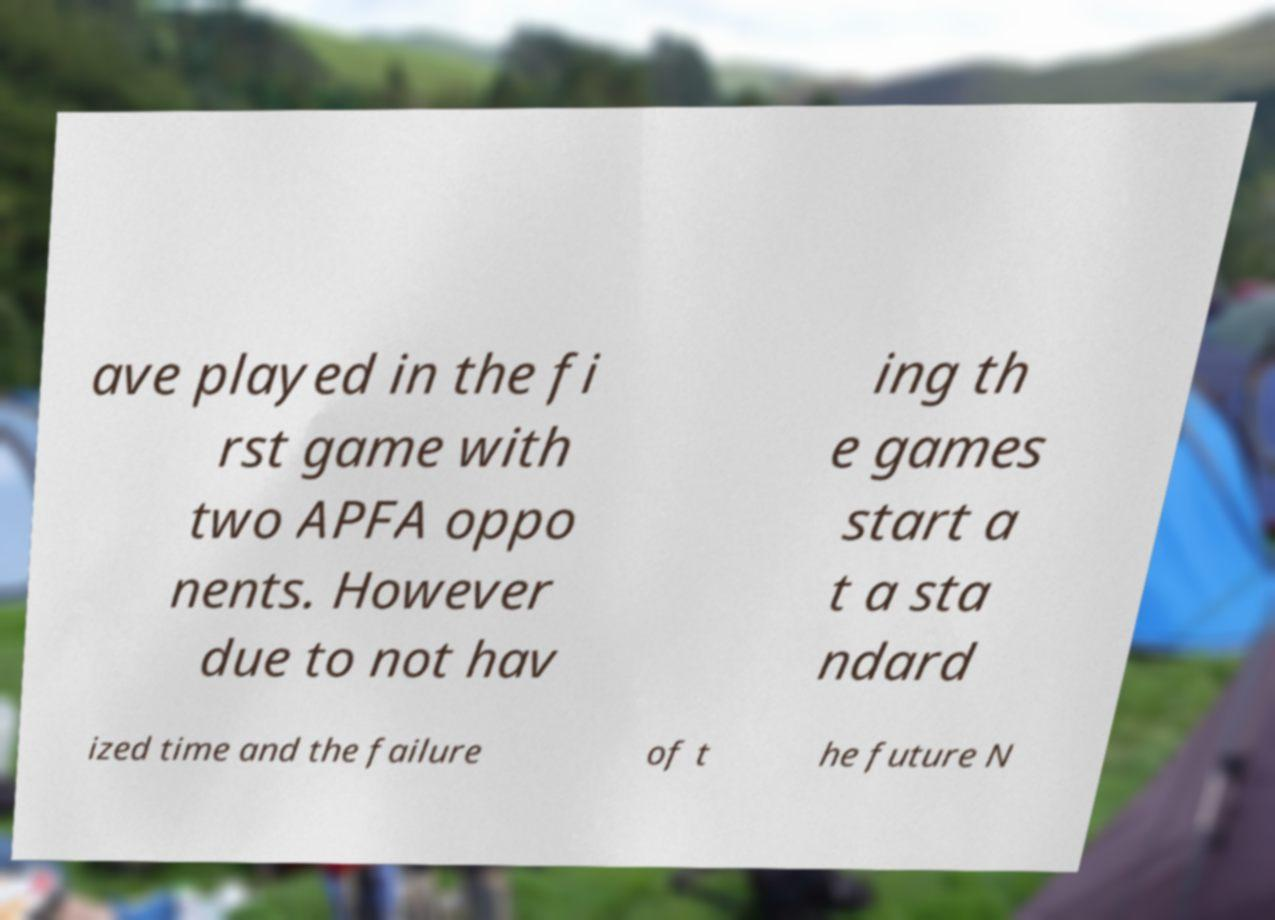For documentation purposes, I need the text within this image transcribed. Could you provide that? ave played in the fi rst game with two APFA oppo nents. However due to not hav ing th e games start a t a sta ndard ized time and the failure of t he future N 